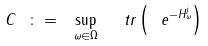<formula> <loc_0><loc_0><loc_500><loc_500>C \ \colon = \ \sup _ { \omega \in \Omega } \ \ t r \left ( \ e ^ { - H _ { \omega } ^ { j } } \right )</formula> 